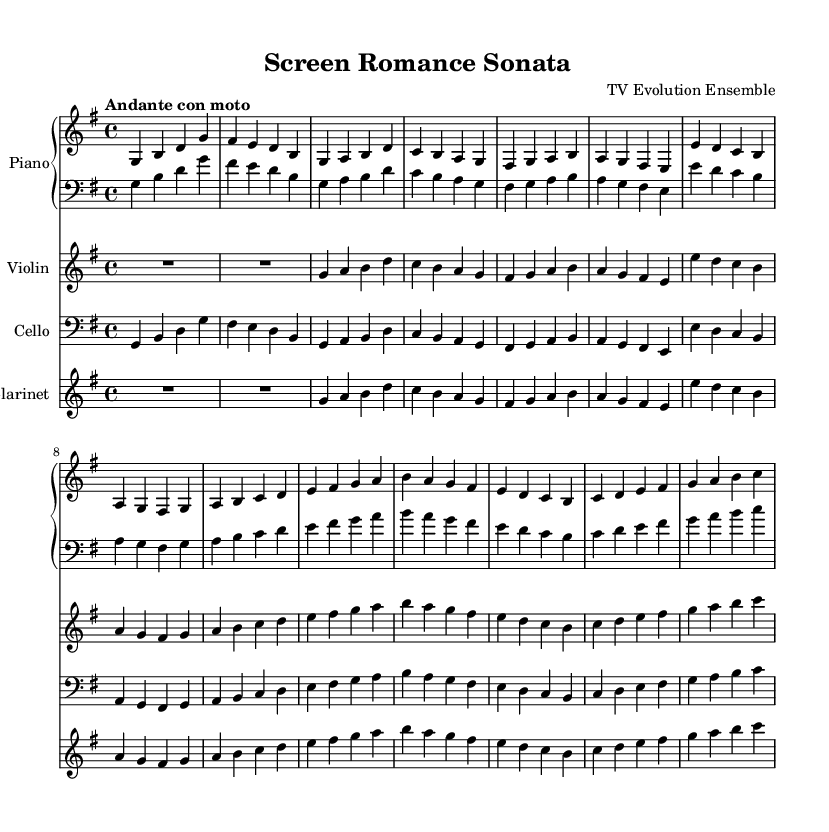What is the key signature of this music? The key signature is indicated by the number of sharps or flats at the beginning of the staff. In this case, it is the G major key signature, which has one sharp (F#).
Answer: G major What is the time signature of this music? The time signature is displayed at the beginning of the score, showing how many beats are in each measure. Here, it shows 4/4, meaning there are four beats per measure and the quarter note gets one beat.
Answer: 4/4 What is the tempo marking for this piece? The tempo is indicated at the beginning of the score with the marking "Andante con moto," which suggests a moderately slow pace with some motion.
Answer: Andante con moto How many measures are in the piano part? To determine this, I count the number of vertical lines (bar lines) that indicate the end of measures in the piano section. There are 12 measures in the piano part.
Answer: 12 Which instruments are included in the ensemble? The instruments are indicated in the score header and each part is labeled. The listed instruments are Piano, Violin, Cello, and Clarinet.
Answer: Piano, Violin, Cello, Clarinet What is the range of the violin part? The violin part indicates notes starting from G above middle C and extends to high B, suggesting its highest and lowest notes in the part. This range indicates a typical violin span.
Answer: G to B What type of musical form does this piece represent? Analyzing the structure, it combines themes and a development section typical of sonata form, reflecting the Romantic style that emphasizes thematic development.
Answer: Sonata form 